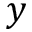<formula> <loc_0><loc_0><loc_500><loc_500>y</formula> 